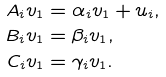<formula> <loc_0><loc_0><loc_500><loc_500>A _ { i } v _ { 1 } & = \alpha _ { i } v _ { 1 } + u _ { i } , \\ B _ { i } v _ { 1 } & = \beta _ { i } v _ { 1 } , \\ C _ { i } v _ { 1 } & = \gamma _ { i } v _ { 1 } .</formula> 